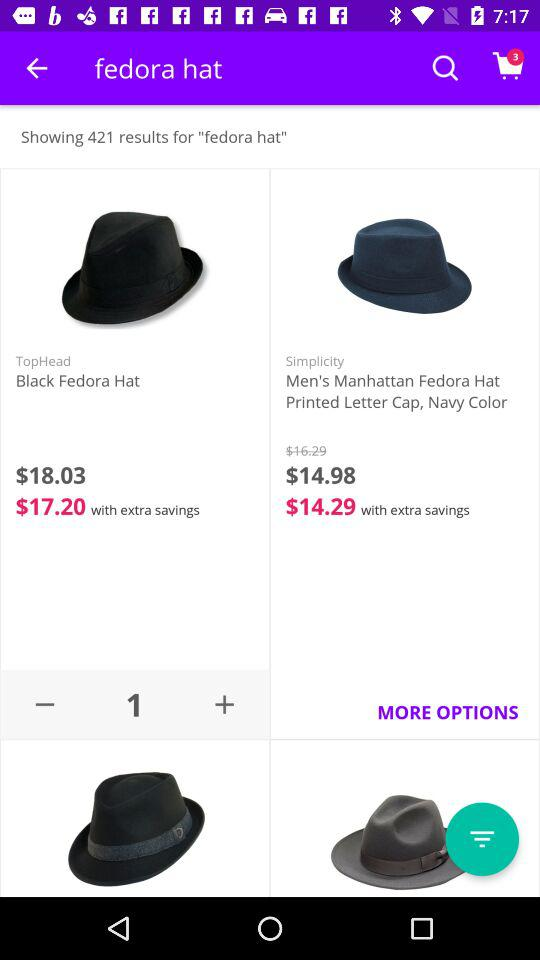What’s the currency of price? The currency of price is dollars. 